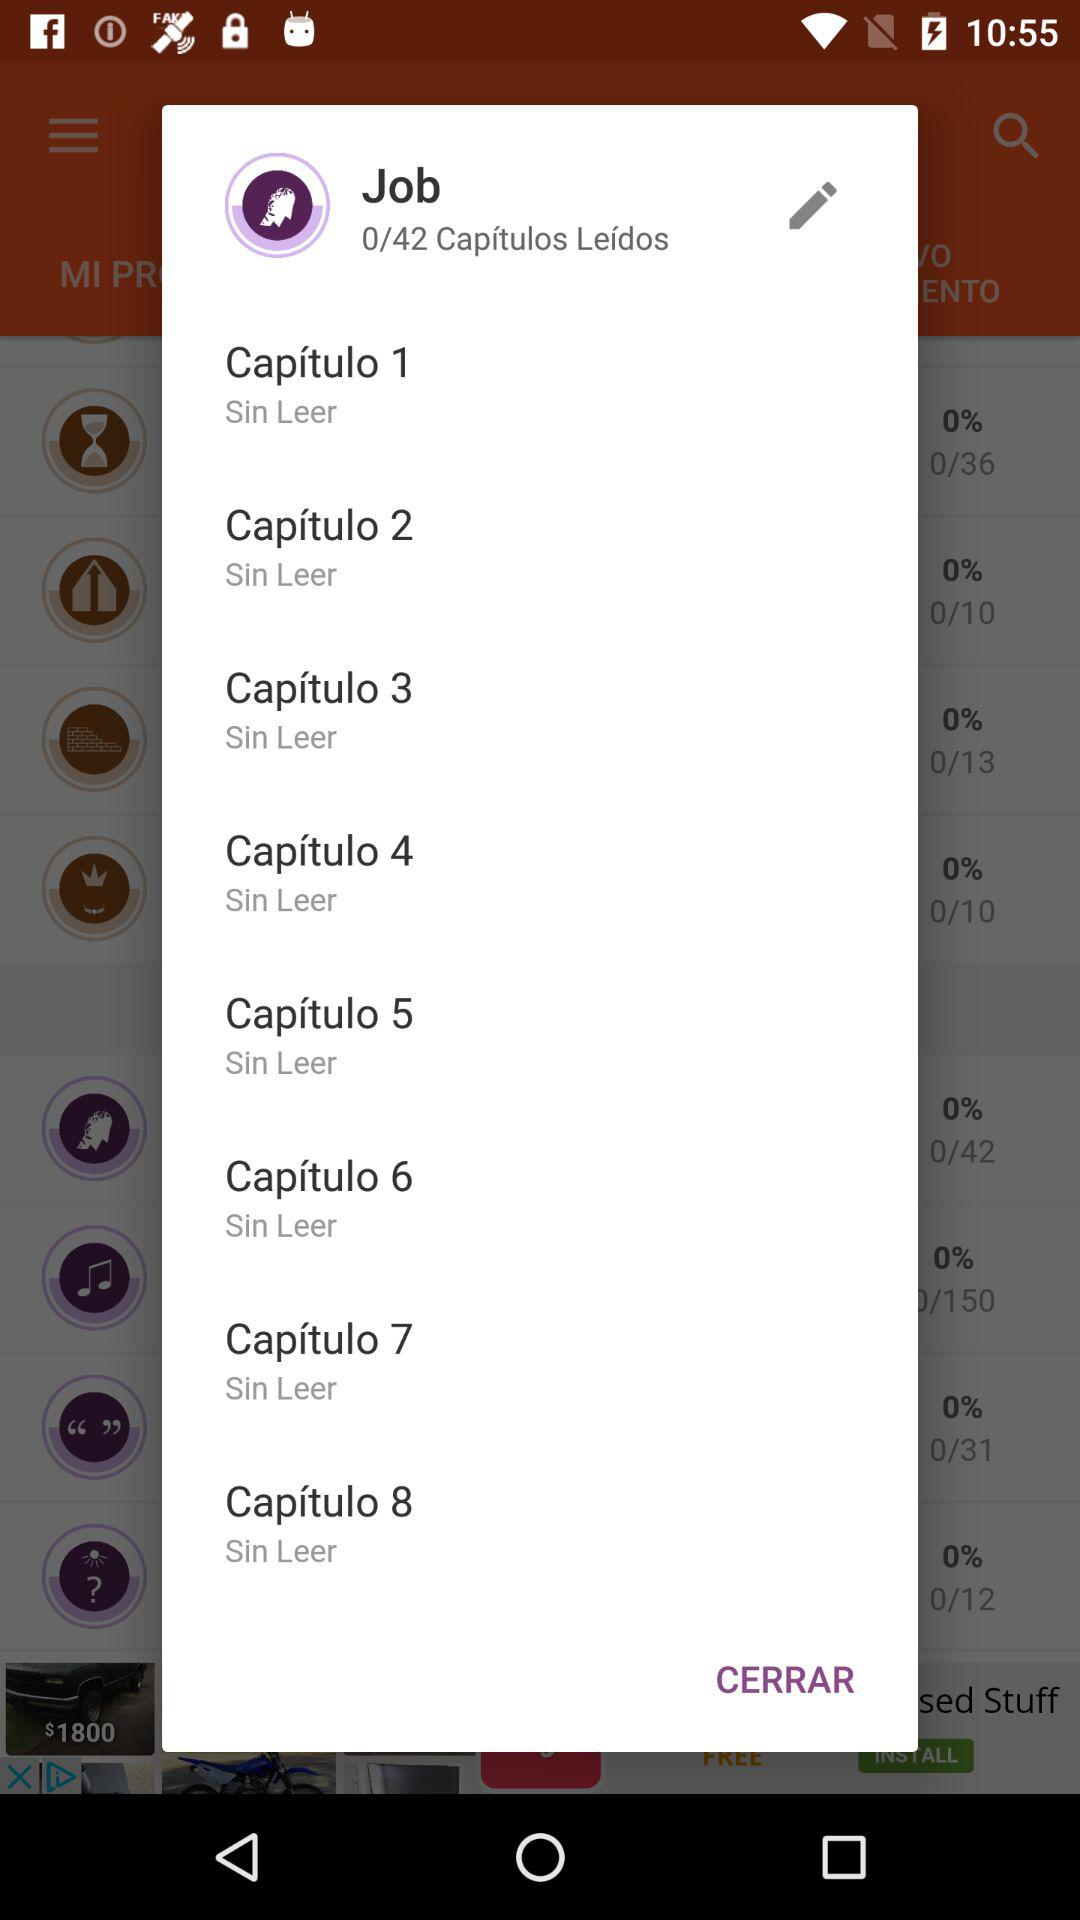How many chapters have not been read?
Answer the question using a single word or phrase. 8 